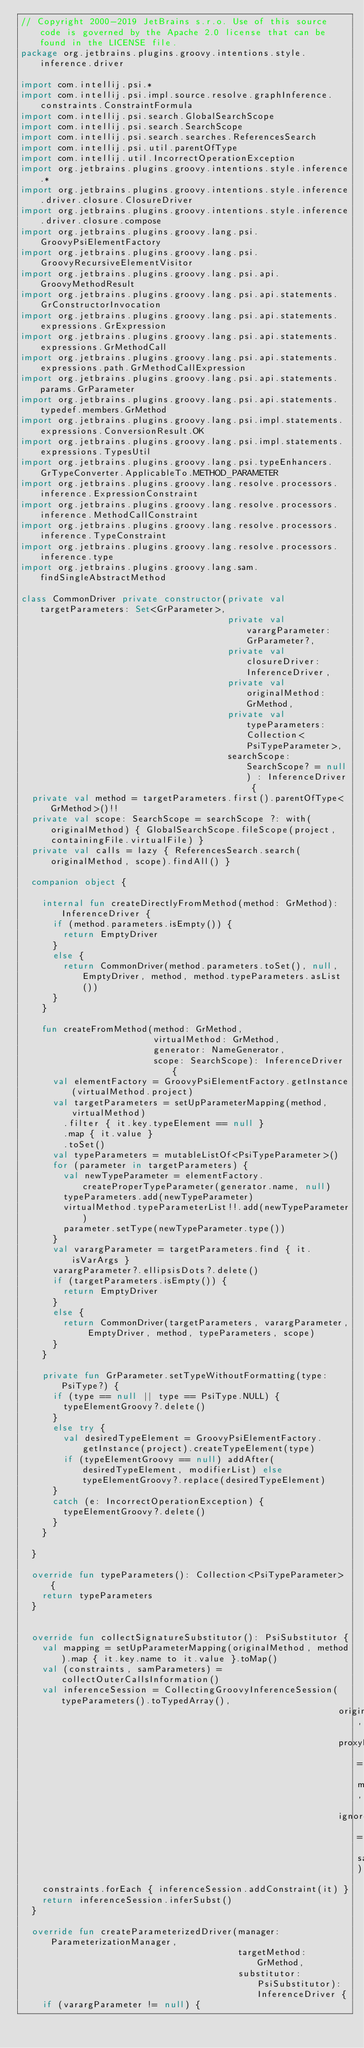<code> <loc_0><loc_0><loc_500><loc_500><_Kotlin_>// Copyright 2000-2019 JetBrains s.r.o. Use of this source code is governed by the Apache 2.0 license that can be found in the LICENSE file.
package org.jetbrains.plugins.groovy.intentions.style.inference.driver

import com.intellij.psi.*
import com.intellij.psi.impl.source.resolve.graphInference.constraints.ConstraintFormula
import com.intellij.psi.search.GlobalSearchScope
import com.intellij.psi.search.SearchScope
import com.intellij.psi.search.searches.ReferencesSearch
import com.intellij.psi.util.parentOfType
import com.intellij.util.IncorrectOperationException
import org.jetbrains.plugins.groovy.intentions.style.inference.*
import org.jetbrains.plugins.groovy.intentions.style.inference.driver.closure.ClosureDriver
import org.jetbrains.plugins.groovy.intentions.style.inference.driver.closure.compose
import org.jetbrains.plugins.groovy.lang.psi.GroovyPsiElementFactory
import org.jetbrains.plugins.groovy.lang.psi.GroovyRecursiveElementVisitor
import org.jetbrains.plugins.groovy.lang.psi.api.GroovyMethodResult
import org.jetbrains.plugins.groovy.lang.psi.api.statements.GrConstructorInvocation
import org.jetbrains.plugins.groovy.lang.psi.api.statements.expressions.GrExpression
import org.jetbrains.plugins.groovy.lang.psi.api.statements.expressions.GrMethodCall
import org.jetbrains.plugins.groovy.lang.psi.api.statements.expressions.path.GrMethodCallExpression
import org.jetbrains.plugins.groovy.lang.psi.api.statements.params.GrParameter
import org.jetbrains.plugins.groovy.lang.psi.api.statements.typedef.members.GrMethod
import org.jetbrains.plugins.groovy.lang.psi.impl.statements.expressions.ConversionResult.OK
import org.jetbrains.plugins.groovy.lang.psi.impl.statements.expressions.TypesUtil
import org.jetbrains.plugins.groovy.lang.psi.typeEnhancers.GrTypeConverter.ApplicableTo.METHOD_PARAMETER
import org.jetbrains.plugins.groovy.lang.resolve.processors.inference.ExpressionConstraint
import org.jetbrains.plugins.groovy.lang.resolve.processors.inference.MethodCallConstraint
import org.jetbrains.plugins.groovy.lang.resolve.processors.inference.TypeConstraint
import org.jetbrains.plugins.groovy.lang.resolve.processors.inference.type
import org.jetbrains.plugins.groovy.lang.sam.findSingleAbstractMethod

class CommonDriver private constructor(private val targetParameters: Set<GrParameter>,
                                       private val varargParameter: GrParameter?,
                                       private val closureDriver: InferenceDriver,
                                       private val originalMethod: GrMethod,
                                       private val typeParameters: Collection<PsiTypeParameter>,
                                       searchScope: SearchScope? = null) : InferenceDriver {
  private val method = targetParameters.first().parentOfType<GrMethod>()!!
  private val scope: SearchScope = searchScope ?: with(originalMethod) { GlobalSearchScope.fileScope(project, containingFile.virtualFile) }
  private val calls = lazy { ReferencesSearch.search(originalMethod, scope).findAll() }

  companion object {

    internal fun createDirectlyFromMethod(method: GrMethod): InferenceDriver {
      if (method.parameters.isEmpty()) {
        return EmptyDriver
      }
      else {
        return CommonDriver(method.parameters.toSet(), null, EmptyDriver, method, method.typeParameters.asList())
      }
    }

    fun createFromMethod(method: GrMethod,
                         virtualMethod: GrMethod,
                         generator: NameGenerator,
                         scope: SearchScope): InferenceDriver {
      val elementFactory = GroovyPsiElementFactory.getInstance(virtualMethod.project)
      val targetParameters = setUpParameterMapping(method, virtualMethod)
        .filter { it.key.typeElement == null }
        .map { it.value }
        .toSet()
      val typeParameters = mutableListOf<PsiTypeParameter>()
      for (parameter in targetParameters) {
        val newTypeParameter = elementFactory.createProperTypeParameter(generator.name, null)
        typeParameters.add(newTypeParameter)
        virtualMethod.typeParameterList!!.add(newTypeParameter)
        parameter.setType(newTypeParameter.type())
      }
      val varargParameter = targetParameters.find { it.isVarArgs }
      varargParameter?.ellipsisDots?.delete()
      if (targetParameters.isEmpty()) {
        return EmptyDriver
      }
      else {
        return CommonDriver(targetParameters, varargParameter, EmptyDriver, method, typeParameters, scope)
      }
    }

    private fun GrParameter.setTypeWithoutFormatting(type: PsiType?) {
      if (type == null || type == PsiType.NULL) {
        typeElementGroovy?.delete()
      }
      else try {
        val desiredTypeElement = GroovyPsiElementFactory.getInstance(project).createTypeElement(type)
        if (typeElementGroovy == null) addAfter(desiredTypeElement, modifierList) else typeElementGroovy?.replace(desiredTypeElement)
      }
      catch (e: IncorrectOperationException) {
        typeElementGroovy?.delete()
      }
    }

  }

  override fun typeParameters(): Collection<PsiTypeParameter> {
    return typeParameters
  }


  override fun collectSignatureSubstitutor(): PsiSubstitutor {
    val mapping = setUpParameterMapping(originalMethod, method).map { it.key.name to it.value }.toMap()
    val (constraints, samParameters) = collectOuterCallsInformation()
    val inferenceSession = CollectingGroovyInferenceSession(typeParameters().toTypedArray(),
                                                            originalMethod,
                                                            proxyMethodMapping = mapping,
                                                            ignoreClosureArguments = samParameters)
    constraints.forEach { inferenceSession.addConstraint(it) }
    return inferenceSession.inferSubst()
  }

  override fun createParameterizedDriver(manager: ParameterizationManager,
                                         targetMethod: GrMethod,
                                         substitutor: PsiSubstitutor): InferenceDriver {
    if (varargParameter != null) {</code> 